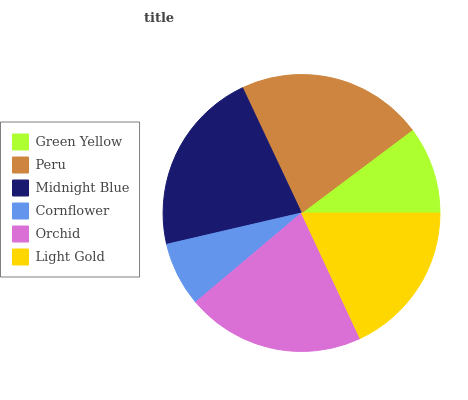Is Cornflower the minimum?
Answer yes or no. Yes. Is Peru the maximum?
Answer yes or no. Yes. Is Midnight Blue the minimum?
Answer yes or no. No. Is Midnight Blue the maximum?
Answer yes or no. No. Is Peru greater than Midnight Blue?
Answer yes or no. Yes. Is Midnight Blue less than Peru?
Answer yes or no. Yes. Is Midnight Blue greater than Peru?
Answer yes or no. No. Is Peru less than Midnight Blue?
Answer yes or no. No. Is Orchid the high median?
Answer yes or no. Yes. Is Light Gold the low median?
Answer yes or no. Yes. Is Cornflower the high median?
Answer yes or no. No. Is Peru the low median?
Answer yes or no. No. 